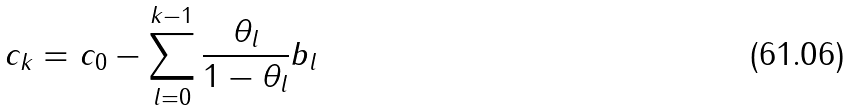<formula> <loc_0><loc_0><loc_500><loc_500>c _ { k } = c _ { 0 } - \sum _ { l = 0 } ^ { k - 1 } \frac { \theta _ { l } } { 1 - \theta _ { l } } b _ { l }</formula> 